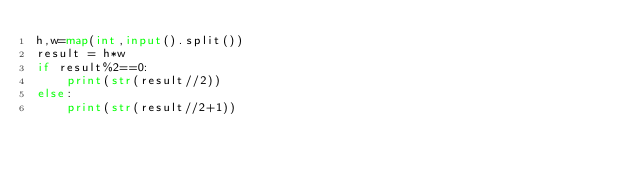<code> <loc_0><loc_0><loc_500><loc_500><_Python_>h,w=map(int,input().split())
result = h*w
if result%2==0:
    print(str(result//2))
else:
    print(str(result//2+1))</code> 